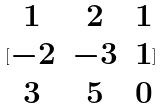<formula> <loc_0><loc_0><loc_500><loc_500>[ \begin{matrix} 1 & 2 & 1 \\ - 2 & - 3 & 1 \\ 3 & 5 & 0 \end{matrix} ]</formula> 